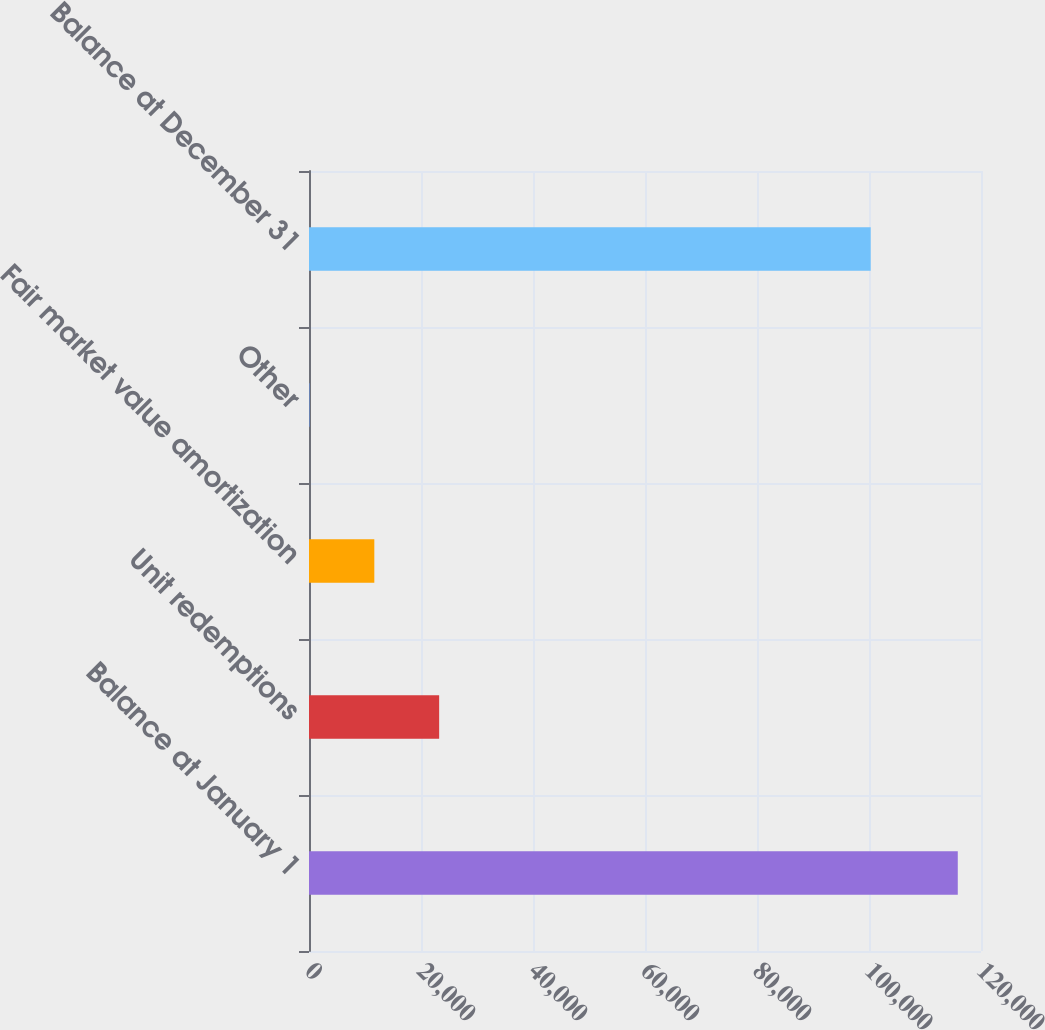<chart> <loc_0><loc_0><loc_500><loc_500><bar_chart><fcel>Balance at January 1<fcel>Unit redemptions<fcel>Fair market value amortization<fcel>Other<fcel>Balance at December 31<nl><fcel>115853<fcel>23241.8<fcel>11665.4<fcel>89<fcel>100304<nl></chart> 